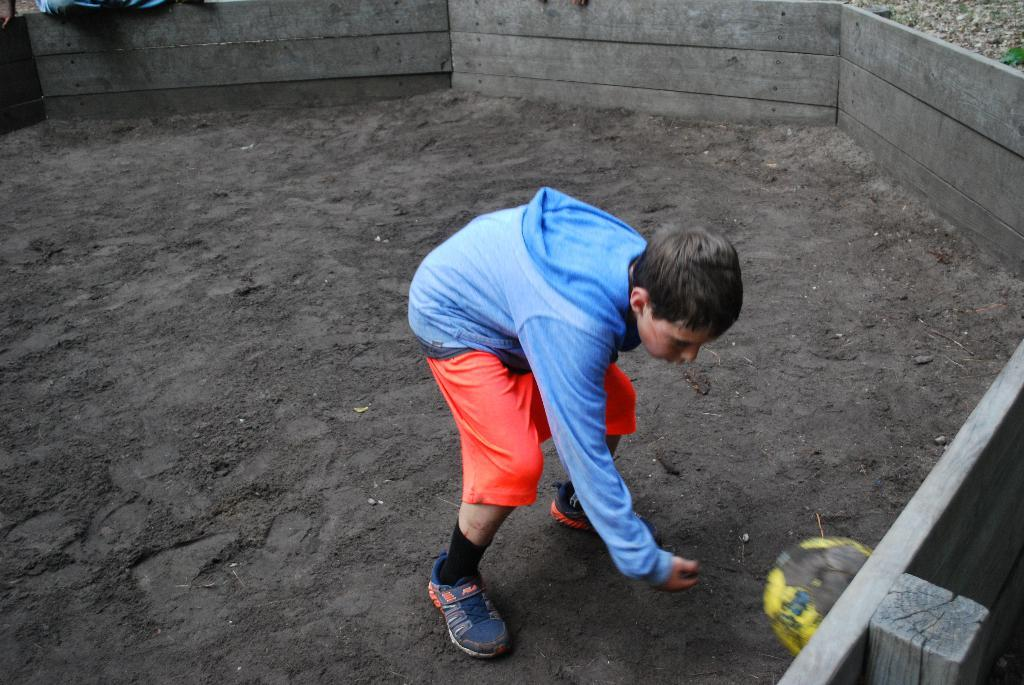Who is the main subject in the image? There is a boy in the image. What is the texture of the ground in the image? There is black sand on the ground in the image. What type of objects can be seen in the image? There are wooden blocks in the image. What type of government is depicted in the image? There is no depiction of a government in the image; it features a boy, black sand, and wooden blocks. What meal is being prepared in the image? There is no meal preparation in the image; it only shows a boy, black sand, and wooden blocks. 